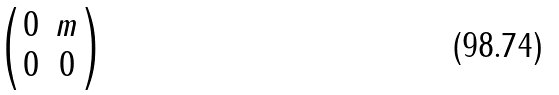<formula> <loc_0><loc_0><loc_500><loc_500>\begin{pmatrix} 0 & m \\ 0 & 0 \end{pmatrix}</formula> 